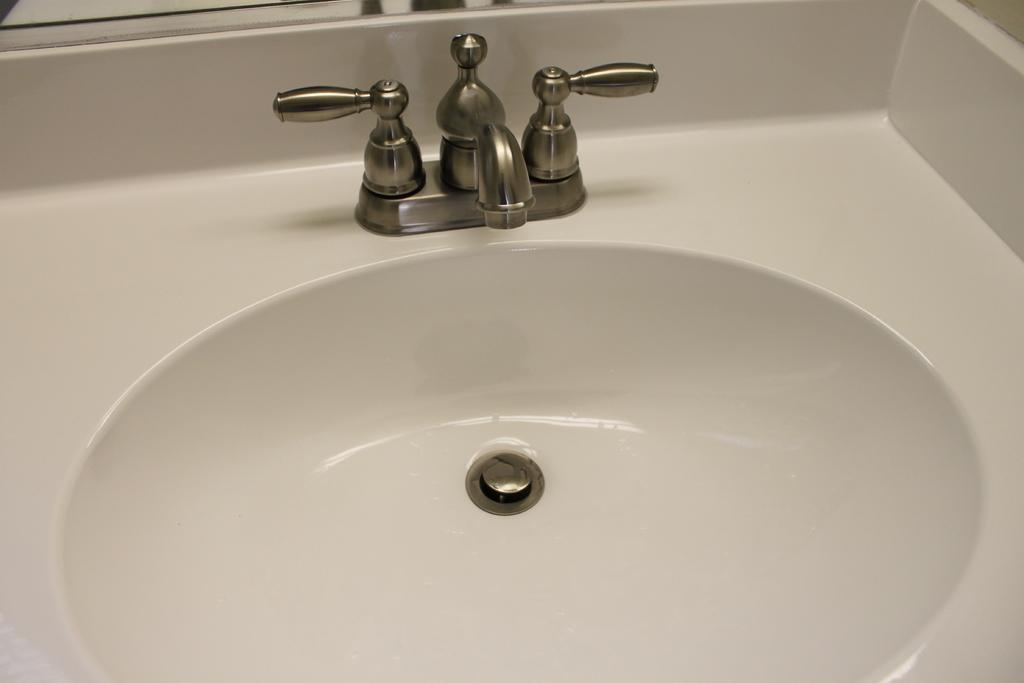What type of fixture is located in the center of the image? There is a white-colored sink in the image. What is the purpose of the fixture next to the sink? There is a tap in the image, which is used for controlling the flow of water. Can you describe the positioning of the sink and tap in the image? Both the sink and the tap are in the center of the image. What type of ice can be seen melting on the sink in the image? There is no ice present in the image; it features a white-colored sink and a tap. How does the stone stretch across the sink in the image? There is no stone present in the image, and therefore it cannot stretch across the sink. 